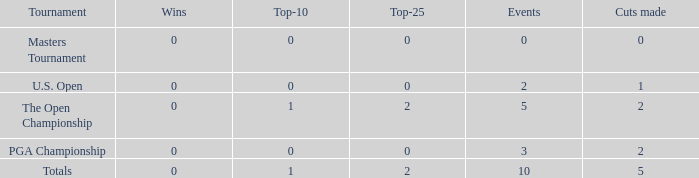What is the total number of top-25s for events with 0 wins? 0.0. 